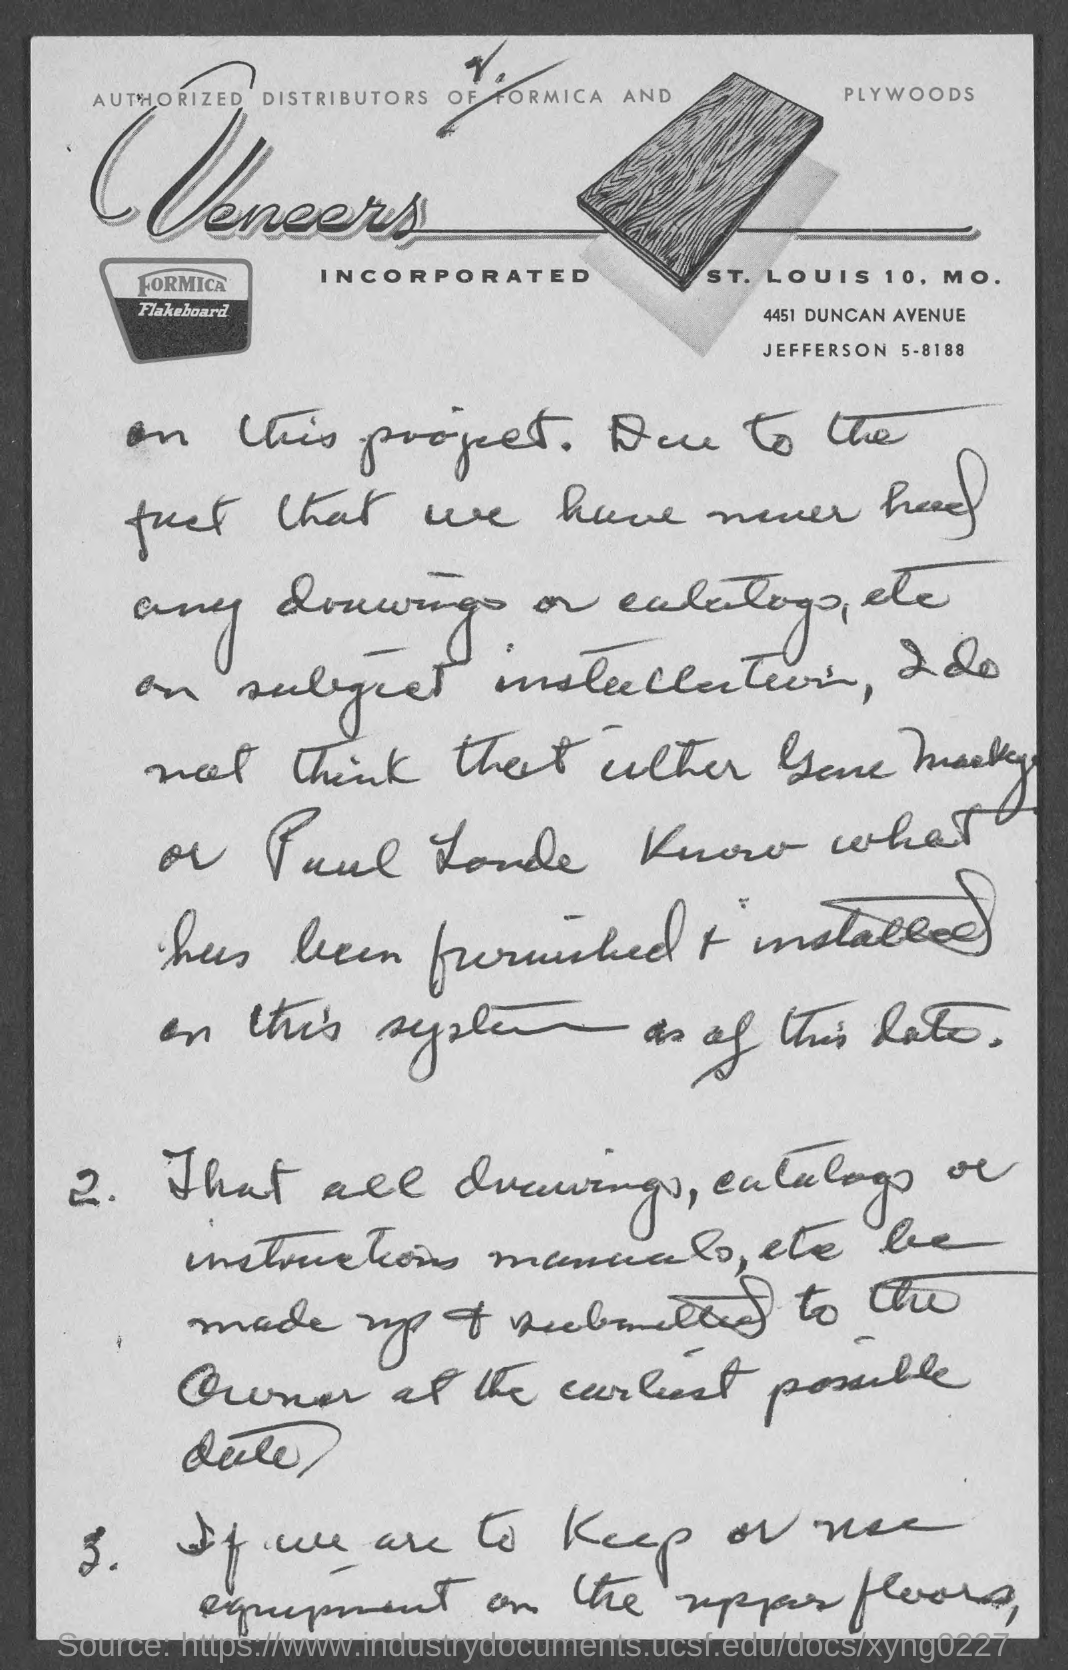What is the name of firm?
Make the answer very short. Veneers. 